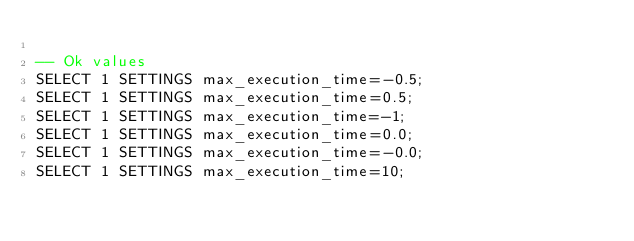<code> <loc_0><loc_0><loc_500><loc_500><_SQL_>
-- Ok values
SELECT 1 SETTINGS max_execution_time=-0.5;
SELECT 1 SETTINGS max_execution_time=0.5;
SELECT 1 SETTINGS max_execution_time=-1;
SELECT 1 SETTINGS max_execution_time=0.0;
SELECT 1 SETTINGS max_execution_time=-0.0;
SELECT 1 SETTINGS max_execution_time=10;
</code> 